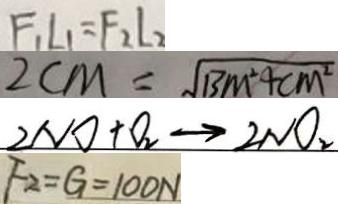<formula> <loc_0><loc_0><loc_500><loc_500>F _ { 1 } L _ { 1 } = F _ { 2 } l _ { 2 } 
 2 c m = \sqrt { B M ^ { 2 } + c m ^ { 2 } } 
 2 N O + O _ { 2 } \rightarrow 2 N O _ { 2 } 
 F _ { 2 } = G = 1 0 0 N</formula> 